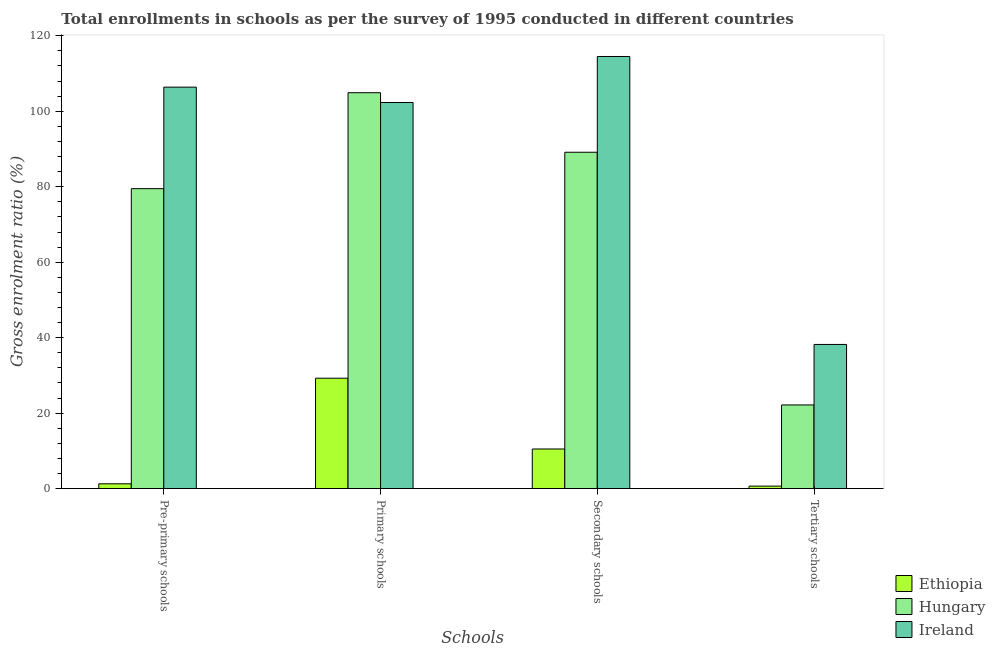Are the number of bars per tick equal to the number of legend labels?
Your response must be concise. Yes. What is the label of the 3rd group of bars from the left?
Your answer should be very brief. Secondary schools. What is the gross enrolment ratio in primary schools in Ethiopia?
Offer a very short reply. 29.27. Across all countries, what is the maximum gross enrolment ratio in secondary schools?
Make the answer very short. 114.5. Across all countries, what is the minimum gross enrolment ratio in tertiary schools?
Provide a succinct answer. 0.67. In which country was the gross enrolment ratio in pre-primary schools maximum?
Provide a succinct answer. Ireland. In which country was the gross enrolment ratio in pre-primary schools minimum?
Your answer should be compact. Ethiopia. What is the total gross enrolment ratio in pre-primary schools in the graph?
Offer a very short reply. 187.16. What is the difference between the gross enrolment ratio in secondary schools in Ireland and that in Ethiopia?
Keep it short and to the point. 103.99. What is the difference between the gross enrolment ratio in secondary schools in Ireland and the gross enrolment ratio in tertiary schools in Ethiopia?
Provide a short and direct response. 113.83. What is the average gross enrolment ratio in pre-primary schools per country?
Offer a very short reply. 62.39. What is the difference between the gross enrolment ratio in pre-primary schools and gross enrolment ratio in secondary schools in Ethiopia?
Give a very brief answer. -9.22. In how many countries, is the gross enrolment ratio in pre-primary schools greater than 64 %?
Make the answer very short. 2. What is the ratio of the gross enrolment ratio in tertiary schools in Ireland to that in Hungary?
Ensure brevity in your answer.  1.72. Is the gross enrolment ratio in primary schools in Hungary less than that in Ireland?
Provide a short and direct response. No. Is the difference between the gross enrolment ratio in pre-primary schools in Ethiopia and Hungary greater than the difference between the gross enrolment ratio in secondary schools in Ethiopia and Hungary?
Provide a short and direct response. Yes. What is the difference between the highest and the second highest gross enrolment ratio in pre-primary schools?
Ensure brevity in your answer.  26.9. What is the difference between the highest and the lowest gross enrolment ratio in tertiary schools?
Give a very brief answer. 37.54. In how many countries, is the gross enrolment ratio in primary schools greater than the average gross enrolment ratio in primary schools taken over all countries?
Make the answer very short. 2. Is the sum of the gross enrolment ratio in pre-primary schools in Ireland and Hungary greater than the maximum gross enrolment ratio in tertiary schools across all countries?
Offer a terse response. Yes. What does the 2nd bar from the left in Primary schools represents?
Keep it short and to the point. Hungary. What does the 1st bar from the right in Tertiary schools represents?
Your answer should be very brief. Ireland. Is it the case that in every country, the sum of the gross enrolment ratio in pre-primary schools and gross enrolment ratio in primary schools is greater than the gross enrolment ratio in secondary schools?
Ensure brevity in your answer.  Yes. How many bars are there?
Offer a very short reply. 12. Are all the bars in the graph horizontal?
Offer a terse response. No. Does the graph contain any zero values?
Give a very brief answer. No. Does the graph contain grids?
Your answer should be compact. No. Where does the legend appear in the graph?
Your answer should be compact. Bottom right. What is the title of the graph?
Provide a short and direct response. Total enrollments in schools as per the survey of 1995 conducted in different countries. What is the label or title of the X-axis?
Provide a succinct answer. Schools. What is the label or title of the Y-axis?
Give a very brief answer. Gross enrolment ratio (%). What is the Gross enrolment ratio (%) in Ethiopia in Pre-primary schools?
Your response must be concise. 1.29. What is the Gross enrolment ratio (%) in Hungary in Pre-primary schools?
Make the answer very short. 79.49. What is the Gross enrolment ratio (%) in Ireland in Pre-primary schools?
Offer a very short reply. 106.38. What is the Gross enrolment ratio (%) in Ethiopia in Primary schools?
Give a very brief answer. 29.27. What is the Gross enrolment ratio (%) in Hungary in Primary schools?
Offer a very short reply. 104.91. What is the Gross enrolment ratio (%) of Ireland in Primary schools?
Provide a short and direct response. 102.31. What is the Gross enrolment ratio (%) in Ethiopia in Secondary schools?
Your response must be concise. 10.52. What is the Gross enrolment ratio (%) of Hungary in Secondary schools?
Give a very brief answer. 89.13. What is the Gross enrolment ratio (%) of Ireland in Secondary schools?
Your response must be concise. 114.5. What is the Gross enrolment ratio (%) of Ethiopia in Tertiary schools?
Your answer should be very brief. 0.67. What is the Gross enrolment ratio (%) in Hungary in Tertiary schools?
Offer a terse response. 22.18. What is the Gross enrolment ratio (%) in Ireland in Tertiary schools?
Keep it short and to the point. 38.21. Across all Schools, what is the maximum Gross enrolment ratio (%) in Ethiopia?
Offer a terse response. 29.27. Across all Schools, what is the maximum Gross enrolment ratio (%) of Hungary?
Ensure brevity in your answer.  104.91. Across all Schools, what is the maximum Gross enrolment ratio (%) in Ireland?
Provide a succinct answer. 114.5. Across all Schools, what is the minimum Gross enrolment ratio (%) in Ethiopia?
Your response must be concise. 0.67. Across all Schools, what is the minimum Gross enrolment ratio (%) of Hungary?
Your response must be concise. 22.18. Across all Schools, what is the minimum Gross enrolment ratio (%) in Ireland?
Your answer should be compact. 38.21. What is the total Gross enrolment ratio (%) of Ethiopia in the graph?
Your response must be concise. 41.75. What is the total Gross enrolment ratio (%) of Hungary in the graph?
Provide a succinct answer. 295.71. What is the total Gross enrolment ratio (%) in Ireland in the graph?
Offer a very short reply. 361.41. What is the difference between the Gross enrolment ratio (%) of Ethiopia in Pre-primary schools and that in Primary schools?
Provide a succinct answer. -27.98. What is the difference between the Gross enrolment ratio (%) in Hungary in Pre-primary schools and that in Primary schools?
Give a very brief answer. -25.42. What is the difference between the Gross enrolment ratio (%) in Ireland in Pre-primary schools and that in Primary schools?
Offer a very short reply. 4.07. What is the difference between the Gross enrolment ratio (%) of Ethiopia in Pre-primary schools and that in Secondary schools?
Keep it short and to the point. -9.22. What is the difference between the Gross enrolment ratio (%) in Hungary in Pre-primary schools and that in Secondary schools?
Ensure brevity in your answer.  -9.65. What is the difference between the Gross enrolment ratio (%) in Ireland in Pre-primary schools and that in Secondary schools?
Give a very brief answer. -8.12. What is the difference between the Gross enrolment ratio (%) of Ethiopia in Pre-primary schools and that in Tertiary schools?
Give a very brief answer. 0.62. What is the difference between the Gross enrolment ratio (%) of Hungary in Pre-primary schools and that in Tertiary schools?
Provide a short and direct response. 57.3. What is the difference between the Gross enrolment ratio (%) of Ireland in Pre-primary schools and that in Tertiary schools?
Your response must be concise. 68.17. What is the difference between the Gross enrolment ratio (%) in Ethiopia in Primary schools and that in Secondary schools?
Your answer should be very brief. 18.75. What is the difference between the Gross enrolment ratio (%) of Hungary in Primary schools and that in Secondary schools?
Make the answer very short. 15.77. What is the difference between the Gross enrolment ratio (%) in Ireland in Primary schools and that in Secondary schools?
Provide a short and direct response. -12.19. What is the difference between the Gross enrolment ratio (%) of Ethiopia in Primary schools and that in Tertiary schools?
Provide a short and direct response. 28.59. What is the difference between the Gross enrolment ratio (%) of Hungary in Primary schools and that in Tertiary schools?
Offer a terse response. 82.72. What is the difference between the Gross enrolment ratio (%) of Ireland in Primary schools and that in Tertiary schools?
Offer a very short reply. 64.1. What is the difference between the Gross enrolment ratio (%) in Ethiopia in Secondary schools and that in Tertiary schools?
Your response must be concise. 9.84. What is the difference between the Gross enrolment ratio (%) of Hungary in Secondary schools and that in Tertiary schools?
Provide a succinct answer. 66.95. What is the difference between the Gross enrolment ratio (%) of Ireland in Secondary schools and that in Tertiary schools?
Your answer should be very brief. 76.29. What is the difference between the Gross enrolment ratio (%) of Ethiopia in Pre-primary schools and the Gross enrolment ratio (%) of Hungary in Primary schools?
Give a very brief answer. -103.62. What is the difference between the Gross enrolment ratio (%) of Ethiopia in Pre-primary schools and the Gross enrolment ratio (%) of Ireland in Primary schools?
Offer a very short reply. -101.02. What is the difference between the Gross enrolment ratio (%) of Hungary in Pre-primary schools and the Gross enrolment ratio (%) of Ireland in Primary schools?
Your response must be concise. -22.83. What is the difference between the Gross enrolment ratio (%) in Ethiopia in Pre-primary schools and the Gross enrolment ratio (%) in Hungary in Secondary schools?
Your answer should be very brief. -87.84. What is the difference between the Gross enrolment ratio (%) in Ethiopia in Pre-primary schools and the Gross enrolment ratio (%) in Ireland in Secondary schools?
Provide a succinct answer. -113.21. What is the difference between the Gross enrolment ratio (%) of Hungary in Pre-primary schools and the Gross enrolment ratio (%) of Ireland in Secondary schools?
Offer a terse response. -35.02. What is the difference between the Gross enrolment ratio (%) of Ethiopia in Pre-primary schools and the Gross enrolment ratio (%) of Hungary in Tertiary schools?
Offer a very short reply. -20.89. What is the difference between the Gross enrolment ratio (%) in Ethiopia in Pre-primary schools and the Gross enrolment ratio (%) in Ireland in Tertiary schools?
Offer a very short reply. -36.92. What is the difference between the Gross enrolment ratio (%) in Hungary in Pre-primary schools and the Gross enrolment ratio (%) in Ireland in Tertiary schools?
Your answer should be very brief. 41.27. What is the difference between the Gross enrolment ratio (%) of Ethiopia in Primary schools and the Gross enrolment ratio (%) of Hungary in Secondary schools?
Keep it short and to the point. -59.87. What is the difference between the Gross enrolment ratio (%) in Ethiopia in Primary schools and the Gross enrolment ratio (%) in Ireland in Secondary schools?
Provide a short and direct response. -85.24. What is the difference between the Gross enrolment ratio (%) in Hungary in Primary schools and the Gross enrolment ratio (%) in Ireland in Secondary schools?
Ensure brevity in your answer.  -9.6. What is the difference between the Gross enrolment ratio (%) of Ethiopia in Primary schools and the Gross enrolment ratio (%) of Hungary in Tertiary schools?
Make the answer very short. 7.08. What is the difference between the Gross enrolment ratio (%) of Ethiopia in Primary schools and the Gross enrolment ratio (%) of Ireland in Tertiary schools?
Your response must be concise. -8.95. What is the difference between the Gross enrolment ratio (%) in Hungary in Primary schools and the Gross enrolment ratio (%) in Ireland in Tertiary schools?
Ensure brevity in your answer.  66.7. What is the difference between the Gross enrolment ratio (%) in Ethiopia in Secondary schools and the Gross enrolment ratio (%) in Hungary in Tertiary schools?
Offer a terse response. -11.67. What is the difference between the Gross enrolment ratio (%) of Ethiopia in Secondary schools and the Gross enrolment ratio (%) of Ireland in Tertiary schools?
Keep it short and to the point. -27.7. What is the difference between the Gross enrolment ratio (%) of Hungary in Secondary schools and the Gross enrolment ratio (%) of Ireland in Tertiary schools?
Offer a terse response. 50.92. What is the average Gross enrolment ratio (%) of Ethiopia per Schools?
Ensure brevity in your answer.  10.44. What is the average Gross enrolment ratio (%) of Hungary per Schools?
Your answer should be very brief. 73.93. What is the average Gross enrolment ratio (%) in Ireland per Schools?
Your answer should be very brief. 90.35. What is the difference between the Gross enrolment ratio (%) of Ethiopia and Gross enrolment ratio (%) of Hungary in Pre-primary schools?
Give a very brief answer. -78.2. What is the difference between the Gross enrolment ratio (%) of Ethiopia and Gross enrolment ratio (%) of Ireland in Pre-primary schools?
Offer a terse response. -105.09. What is the difference between the Gross enrolment ratio (%) of Hungary and Gross enrolment ratio (%) of Ireland in Pre-primary schools?
Make the answer very short. -26.89. What is the difference between the Gross enrolment ratio (%) in Ethiopia and Gross enrolment ratio (%) in Hungary in Primary schools?
Ensure brevity in your answer.  -75.64. What is the difference between the Gross enrolment ratio (%) of Ethiopia and Gross enrolment ratio (%) of Ireland in Primary schools?
Your response must be concise. -73.04. What is the difference between the Gross enrolment ratio (%) in Hungary and Gross enrolment ratio (%) in Ireland in Primary schools?
Your answer should be compact. 2.6. What is the difference between the Gross enrolment ratio (%) in Ethiopia and Gross enrolment ratio (%) in Hungary in Secondary schools?
Keep it short and to the point. -78.62. What is the difference between the Gross enrolment ratio (%) in Ethiopia and Gross enrolment ratio (%) in Ireland in Secondary schools?
Your answer should be compact. -103.99. What is the difference between the Gross enrolment ratio (%) of Hungary and Gross enrolment ratio (%) of Ireland in Secondary schools?
Provide a short and direct response. -25.37. What is the difference between the Gross enrolment ratio (%) in Ethiopia and Gross enrolment ratio (%) in Hungary in Tertiary schools?
Keep it short and to the point. -21.51. What is the difference between the Gross enrolment ratio (%) in Ethiopia and Gross enrolment ratio (%) in Ireland in Tertiary schools?
Provide a short and direct response. -37.54. What is the difference between the Gross enrolment ratio (%) of Hungary and Gross enrolment ratio (%) of Ireland in Tertiary schools?
Give a very brief answer. -16.03. What is the ratio of the Gross enrolment ratio (%) in Ethiopia in Pre-primary schools to that in Primary schools?
Ensure brevity in your answer.  0.04. What is the ratio of the Gross enrolment ratio (%) in Hungary in Pre-primary schools to that in Primary schools?
Keep it short and to the point. 0.76. What is the ratio of the Gross enrolment ratio (%) in Ireland in Pre-primary schools to that in Primary schools?
Ensure brevity in your answer.  1.04. What is the ratio of the Gross enrolment ratio (%) in Ethiopia in Pre-primary schools to that in Secondary schools?
Your response must be concise. 0.12. What is the ratio of the Gross enrolment ratio (%) of Hungary in Pre-primary schools to that in Secondary schools?
Your response must be concise. 0.89. What is the ratio of the Gross enrolment ratio (%) of Ireland in Pre-primary schools to that in Secondary schools?
Give a very brief answer. 0.93. What is the ratio of the Gross enrolment ratio (%) of Ethiopia in Pre-primary schools to that in Tertiary schools?
Provide a short and direct response. 1.92. What is the ratio of the Gross enrolment ratio (%) in Hungary in Pre-primary schools to that in Tertiary schools?
Give a very brief answer. 3.58. What is the ratio of the Gross enrolment ratio (%) in Ireland in Pre-primary schools to that in Tertiary schools?
Your answer should be very brief. 2.78. What is the ratio of the Gross enrolment ratio (%) of Ethiopia in Primary schools to that in Secondary schools?
Keep it short and to the point. 2.78. What is the ratio of the Gross enrolment ratio (%) of Hungary in Primary schools to that in Secondary schools?
Make the answer very short. 1.18. What is the ratio of the Gross enrolment ratio (%) of Ireland in Primary schools to that in Secondary schools?
Your answer should be very brief. 0.89. What is the ratio of the Gross enrolment ratio (%) in Ethiopia in Primary schools to that in Tertiary schools?
Offer a terse response. 43.46. What is the ratio of the Gross enrolment ratio (%) of Hungary in Primary schools to that in Tertiary schools?
Make the answer very short. 4.73. What is the ratio of the Gross enrolment ratio (%) in Ireland in Primary schools to that in Tertiary schools?
Keep it short and to the point. 2.68. What is the ratio of the Gross enrolment ratio (%) in Ethiopia in Secondary schools to that in Tertiary schools?
Provide a short and direct response. 15.61. What is the ratio of the Gross enrolment ratio (%) of Hungary in Secondary schools to that in Tertiary schools?
Keep it short and to the point. 4.02. What is the ratio of the Gross enrolment ratio (%) of Ireland in Secondary schools to that in Tertiary schools?
Keep it short and to the point. 3. What is the difference between the highest and the second highest Gross enrolment ratio (%) in Ethiopia?
Make the answer very short. 18.75. What is the difference between the highest and the second highest Gross enrolment ratio (%) of Hungary?
Keep it short and to the point. 15.77. What is the difference between the highest and the second highest Gross enrolment ratio (%) in Ireland?
Provide a succinct answer. 8.12. What is the difference between the highest and the lowest Gross enrolment ratio (%) of Ethiopia?
Provide a succinct answer. 28.59. What is the difference between the highest and the lowest Gross enrolment ratio (%) of Hungary?
Provide a succinct answer. 82.72. What is the difference between the highest and the lowest Gross enrolment ratio (%) of Ireland?
Offer a terse response. 76.29. 